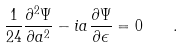<formula> <loc_0><loc_0><loc_500><loc_500>\frac { 1 } { 2 4 } \frac { \partial ^ { 2 } \Psi } { \partial a ^ { 2 } } - i a \frac { \partial \Psi } { \partial \epsilon } = 0 \quad .</formula> 